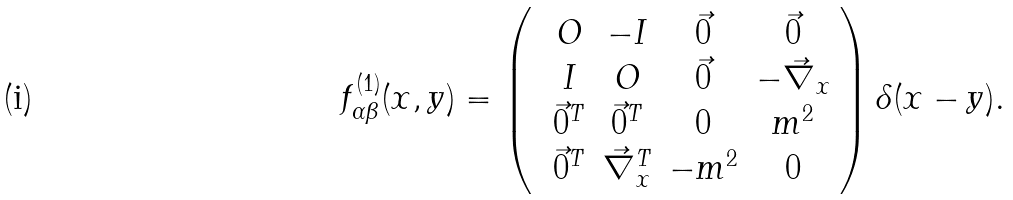<formula> <loc_0><loc_0><loc_500><loc_500>f ^ { ( 1 ) } _ { \alpha \beta } ( x , y ) = \left ( \ \begin{array} { c c c c } O & - I & \vec { 0 } & \vec { 0 } \\ I & O & \vec { 0 } & - \vec { \nabla } _ { x } \\ \vec { 0 } ^ { T } & \vec { 0 } ^ { T } & 0 & m ^ { 2 } \\ \vec { 0 } ^ { T } & \vec { \nabla } ^ { T } _ { x } & - m ^ { 2 } & 0 \end{array} \right ) \delta ( x - y ) .</formula> 